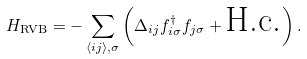<formula> <loc_0><loc_0><loc_500><loc_500>H _ { \text {RVB} } = - \sum _ { \langle i j \rangle , \sigma } \left ( \Delta _ { i j } f ^ { \dagger } _ { i \sigma } f _ { j \sigma } + \text {H.c.} \right ) .</formula> 